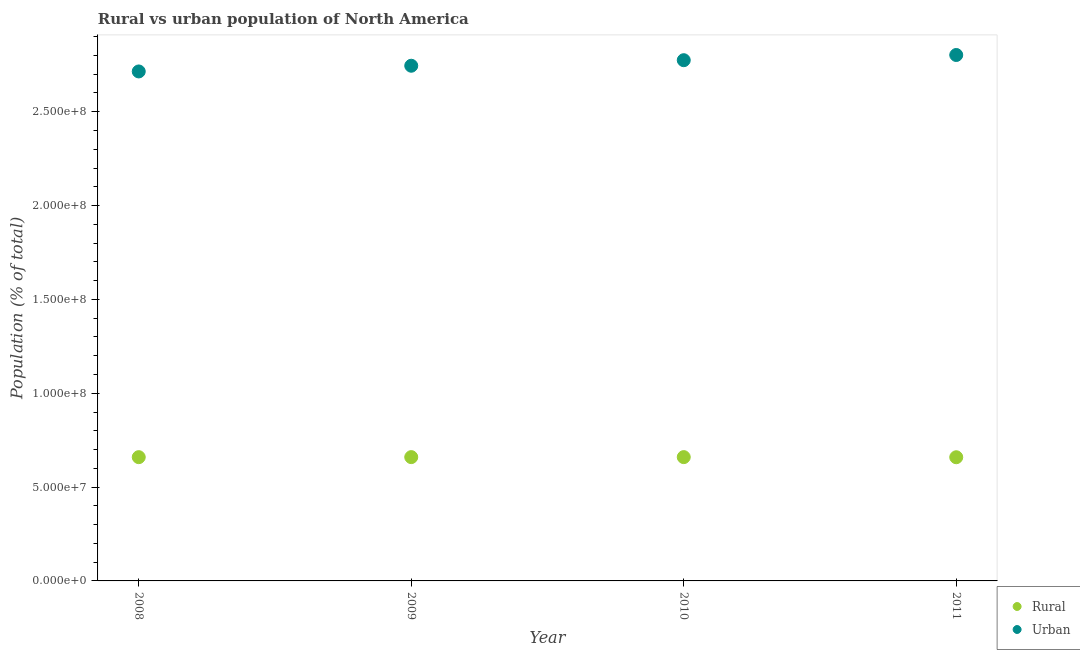How many different coloured dotlines are there?
Keep it short and to the point. 2. What is the rural population density in 2011?
Keep it short and to the point. 6.59e+07. Across all years, what is the maximum urban population density?
Your response must be concise. 2.80e+08. Across all years, what is the minimum urban population density?
Make the answer very short. 2.71e+08. What is the total urban population density in the graph?
Make the answer very short. 1.10e+09. What is the difference between the rural population density in 2008 and that in 2011?
Your answer should be very brief. 4.41e+04. What is the difference between the rural population density in 2010 and the urban population density in 2009?
Offer a very short reply. -2.09e+08. What is the average rural population density per year?
Make the answer very short. 6.59e+07. In the year 2010, what is the difference between the rural population density and urban population density?
Provide a short and direct response. -2.11e+08. What is the ratio of the rural population density in 2008 to that in 2010?
Keep it short and to the point. 1. Is the urban population density in 2008 less than that in 2011?
Offer a very short reply. Yes. Is the difference between the urban population density in 2009 and 2010 greater than the difference between the rural population density in 2009 and 2010?
Your answer should be very brief. No. What is the difference between the highest and the second highest urban population density?
Keep it short and to the point. 2.78e+06. What is the difference between the highest and the lowest urban population density?
Your answer should be compact. 8.77e+06. Is the sum of the rural population density in 2009 and 2011 greater than the maximum urban population density across all years?
Provide a succinct answer. No. Does the rural population density monotonically increase over the years?
Make the answer very short. No. Is the rural population density strictly greater than the urban population density over the years?
Offer a terse response. No. Is the urban population density strictly less than the rural population density over the years?
Provide a short and direct response. No. How many years are there in the graph?
Give a very brief answer. 4. What is the difference between two consecutive major ticks on the Y-axis?
Offer a very short reply. 5.00e+07. Are the values on the major ticks of Y-axis written in scientific E-notation?
Your answer should be very brief. Yes. Does the graph contain any zero values?
Give a very brief answer. No. Does the graph contain grids?
Keep it short and to the point. No. Where does the legend appear in the graph?
Provide a short and direct response. Bottom right. How many legend labels are there?
Make the answer very short. 2. What is the title of the graph?
Offer a very short reply. Rural vs urban population of North America. Does "Primary completion rate" appear as one of the legend labels in the graph?
Your answer should be compact. No. What is the label or title of the Y-axis?
Your answer should be very brief. Population (% of total). What is the Population (% of total) in Rural in 2008?
Ensure brevity in your answer.  6.59e+07. What is the Population (% of total) in Urban in 2008?
Make the answer very short. 2.71e+08. What is the Population (% of total) in Rural in 2009?
Make the answer very short. 6.60e+07. What is the Population (% of total) of Urban in 2009?
Provide a succinct answer. 2.74e+08. What is the Population (% of total) of Rural in 2010?
Give a very brief answer. 6.60e+07. What is the Population (% of total) in Urban in 2010?
Offer a very short reply. 2.77e+08. What is the Population (% of total) of Rural in 2011?
Give a very brief answer. 6.59e+07. What is the Population (% of total) in Urban in 2011?
Ensure brevity in your answer.  2.80e+08. Across all years, what is the maximum Population (% of total) in Rural?
Your response must be concise. 6.60e+07. Across all years, what is the maximum Population (% of total) in Urban?
Your response must be concise. 2.80e+08. Across all years, what is the minimum Population (% of total) of Rural?
Provide a short and direct response. 6.59e+07. Across all years, what is the minimum Population (% of total) of Urban?
Keep it short and to the point. 2.71e+08. What is the total Population (% of total) in Rural in the graph?
Your answer should be compact. 2.64e+08. What is the total Population (% of total) in Urban in the graph?
Give a very brief answer. 1.10e+09. What is the difference between the Population (% of total) in Rural in 2008 and that in 2009?
Your answer should be compact. -2.22e+04. What is the difference between the Population (% of total) in Urban in 2008 and that in 2009?
Ensure brevity in your answer.  -3.04e+06. What is the difference between the Population (% of total) of Rural in 2008 and that in 2010?
Your answer should be compact. -1.98e+04. What is the difference between the Population (% of total) of Urban in 2008 and that in 2010?
Provide a short and direct response. -5.99e+06. What is the difference between the Population (% of total) in Rural in 2008 and that in 2011?
Provide a succinct answer. 4.41e+04. What is the difference between the Population (% of total) in Urban in 2008 and that in 2011?
Your answer should be very brief. -8.77e+06. What is the difference between the Population (% of total) in Rural in 2009 and that in 2010?
Keep it short and to the point. 2403. What is the difference between the Population (% of total) in Urban in 2009 and that in 2010?
Your answer should be compact. -2.95e+06. What is the difference between the Population (% of total) in Rural in 2009 and that in 2011?
Make the answer very short. 6.63e+04. What is the difference between the Population (% of total) of Urban in 2009 and that in 2011?
Your response must be concise. -5.73e+06. What is the difference between the Population (% of total) of Rural in 2010 and that in 2011?
Your response must be concise. 6.39e+04. What is the difference between the Population (% of total) of Urban in 2010 and that in 2011?
Give a very brief answer. -2.78e+06. What is the difference between the Population (% of total) in Rural in 2008 and the Population (% of total) in Urban in 2009?
Offer a terse response. -2.09e+08. What is the difference between the Population (% of total) in Rural in 2008 and the Population (% of total) in Urban in 2010?
Make the answer very short. -2.12e+08. What is the difference between the Population (% of total) of Rural in 2008 and the Population (% of total) of Urban in 2011?
Provide a short and direct response. -2.14e+08. What is the difference between the Population (% of total) in Rural in 2009 and the Population (% of total) in Urban in 2010?
Your response must be concise. -2.11e+08. What is the difference between the Population (% of total) in Rural in 2009 and the Population (% of total) in Urban in 2011?
Offer a very short reply. -2.14e+08. What is the difference between the Population (% of total) of Rural in 2010 and the Population (% of total) of Urban in 2011?
Keep it short and to the point. -2.14e+08. What is the average Population (% of total) of Rural per year?
Keep it short and to the point. 6.59e+07. What is the average Population (% of total) of Urban per year?
Your answer should be very brief. 2.76e+08. In the year 2008, what is the difference between the Population (% of total) in Rural and Population (% of total) in Urban?
Provide a short and direct response. -2.06e+08. In the year 2009, what is the difference between the Population (% of total) of Rural and Population (% of total) of Urban?
Your answer should be very brief. -2.09e+08. In the year 2010, what is the difference between the Population (% of total) in Rural and Population (% of total) in Urban?
Offer a very short reply. -2.11e+08. In the year 2011, what is the difference between the Population (% of total) in Rural and Population (% of total) in Urban?
Give a very brief answer. -2.14e+08. What is the ratio of the Population (% of total) in Urban in 2008 to that in 2009?
Ensure brevity in your answer.  0.99. What is the ratio of the Population (% of total) of Rural in 2008 to that in 2010?
Keep it short and to the point. 1. What is the ratio of the Population (% of total) in Urban in 2008 to that in 2010?
Your answer should be compact. 0.98. What is the ratio of the Population (% of total) of Rural in 2008 to that in 2011?
Give a very brief answer. 1. What is the ratio of the Population (% of total) in Urban in 2008 to that in 2011?
Your response must be concise. 0.97. What is the ratio of the Population (% of total) of Rural in 2009 to that in 2010?
Ensure brevity in your answer.  1. What is the ratio of the Population (% of total) of Urban in 2009 to that in 2010?
Provide a short and direct response. 0.99. What is the ratio of the Population (% of total) of Rural in 2009 to that in 2011?
Your response must be concise. 1. What is the ratio of the Population (% of total) in Urban in 2009 to that in 2011?
Offer a terse response. 0.98. What is the ratio of the Population (% of total) of Urban in 2010 to that in 2011?
Ensure brevity in your answer.  0.99. What is the difference between the highest and the second highest Population (% of total) in Rural?
Ensure brevity in your answer.  2403. What is the difference between the highest and the second highest Population (% of total) of Urban?
Offer a terse response. 2.78e+06. What is the difference between the highest and the lowest Population (% of total) of Rural?
Offer a terse response. 6.63e+04. What is the difference between the highest and the lowest Population (% of total) in Urban?
Make the answer very short. 8.77e+06. 